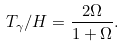<formula> <loc_0><loc_0><loc_500><loc_500>T _ { \gamma } / H = \frac { 2 \Omega } { 1 + \Omega } .</formula> 